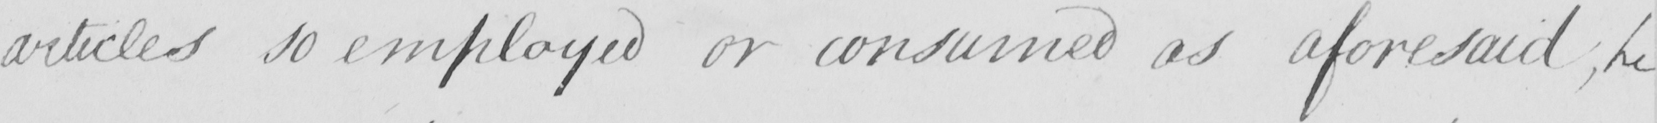What text is written in this handwritten line? articles so employed or consumed as aforesaid  ; he 